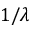<formula> <loc_0><loc_0><loc_500><loc_500>1 / \lambda</formula> 